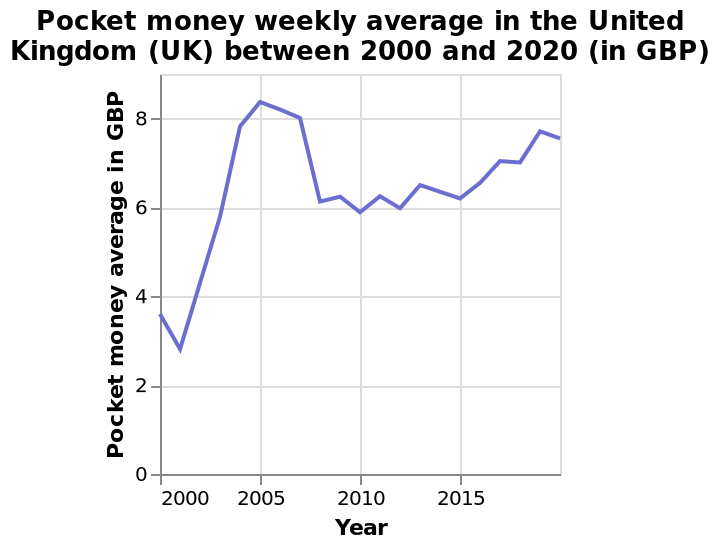<image>
please describe the details of the chart This is a line chart labeled Pocket money weekly average in the United Kingdom (UK) between 2000 and 2020 (in GBP). There is a linear scale with a minimum of 0 and a maximum of 8 on the y-axis, marked Pocket money average in GBP. On the x-axis, Year is plotted using a linear scale from 2000 to 2015. How many years does the line chart cover? The line chart covers a period of 20 years, from 2000 to 2020. What is the title of the line chart?  The title of the line chart is "Pocket money weekly average in the United Kingdom (UK) between 2000 and 2020 (in GBP)." Does the line chart cover a period of 20 years, from 1990 to 2010? No.The line chart covers a period of 20 years, from 2000 to 2020. 